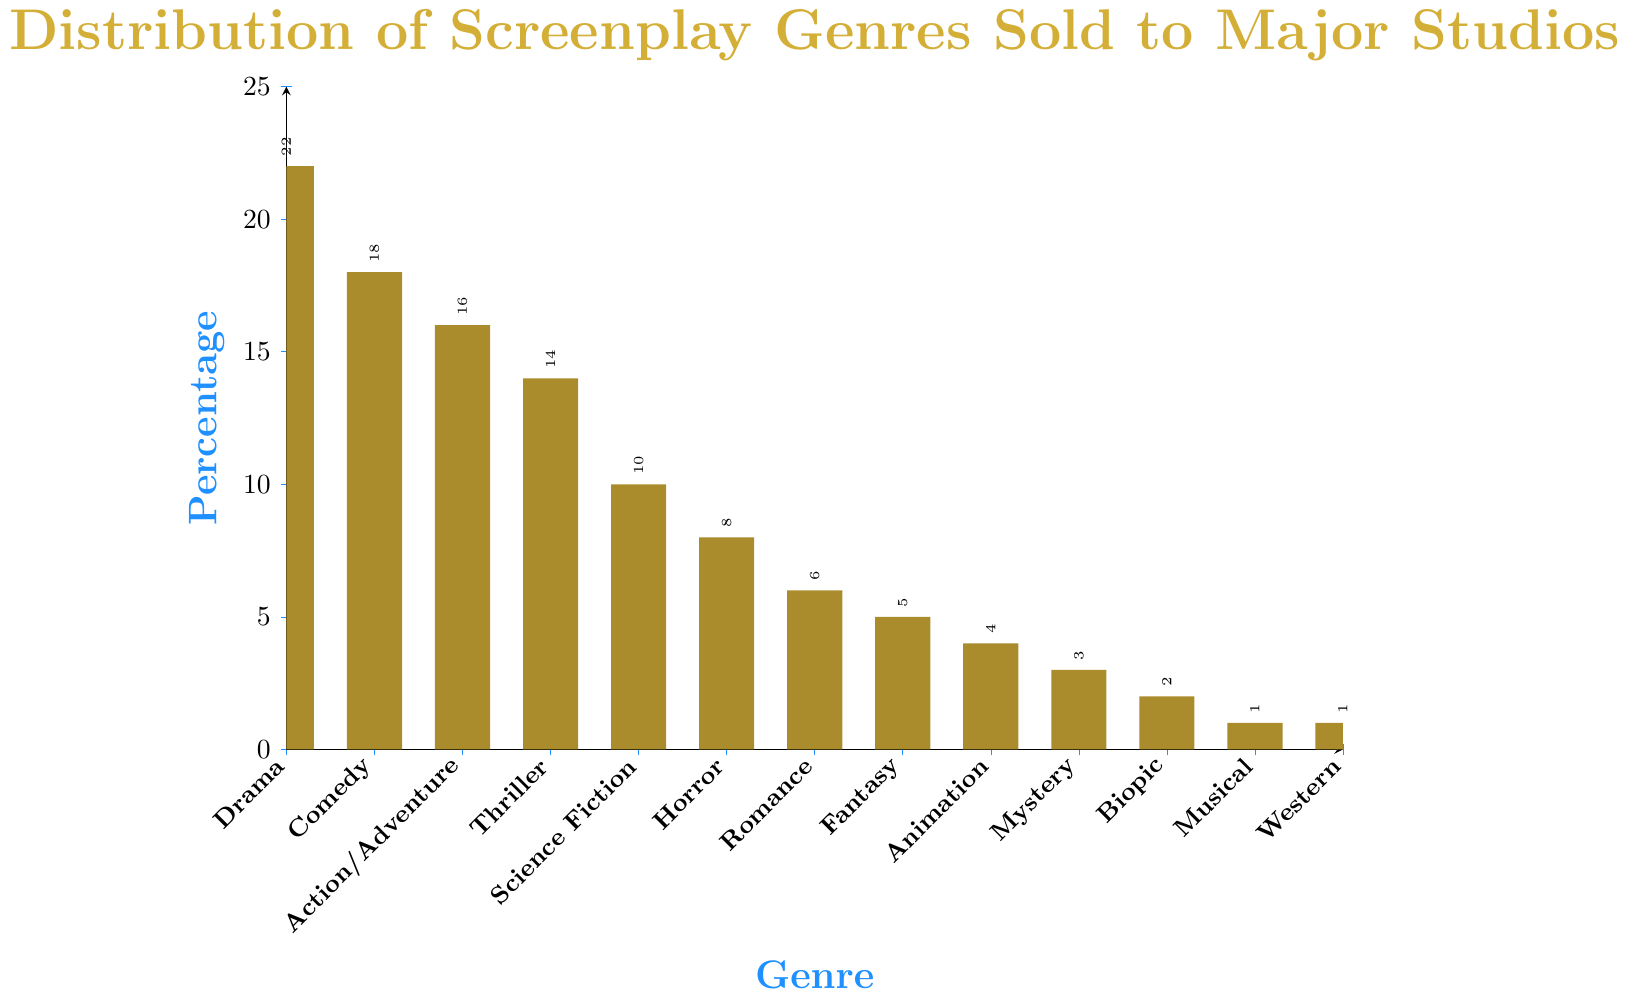Which genre is the most sold to major studios? By looking at the bar chart, we can see that the highest bar represents Drama. Therefore, Drama is the most sold screenplay genre to major studios.
Answer: Drama Which genre is the least sold to major studios? The smallest bars in the chart are for Musical and Western, each representing just 1%.
Answer: Musical and Western How much more popular is Drama compared to Comedy in terms of percentage? The percentage for Drama is 22%, and for Comedy, it is 18%. The difference is 22% - 18% = 4%.
Answer: 4% If you combine the percentages for Horror, Romance, Fantasy, and Musical, what percentage do you get? Adding up the percentages for Horror (8%), Romance (6%), Fantasy (5%), and Musical (1%), the total is 8% + 6% + 5% + 1% = 20%.
Answer: 20% Which genres have a higher percentage than Science Fiction? By looking at the bars, the genres with higher percentages than Science Fiction (10%) are Drama (22%), Comedy (18%), Action/Adventure (16%), and Thriller (14%).
Answer: Drama, Comedy, Action/Adventure, Thriller What is the combined percentage for Thriller and Animation? The percentage for Thriller is 14% and for Animation, it is 4%. Adding them together gives 14% + 4% = 18%.
Answer: 18% Are there more genres that have a percentage less than or equal to 5% or more than 5%? By counting the genres, those with ≤5%: Fantasy (5%), Animation (4%), Mystery (3%), Biopic (2%), Musical (1%), Western (1%) add up to 6 genres. Those with >5%: Drama, Comedy, Action/Adventure, Thriller, Science Fiction, Horror, Romance add up to 7 genres. Thus, there are more genres with percentages greater than 5%.
Answer: More genres have a percentage greater than 5% What is the average percentage of the three least popular genres? The three least popular genres are Musical, Western, and Biopic, with percentages 1%, 1%, and 2% respectively. The average percentage is calculated as (1 + 1 + 2) / 3 = 4 / 3 ≈ 1.33%.
Answer: 1.33% What is the difference in popularity between Action/Adventure and Science Fiction? The percentage for Action/Adventure is 16%, and for Science Fiction, it is 10%. The difference is 16% - 10% = 6%.
Answer: 6% 